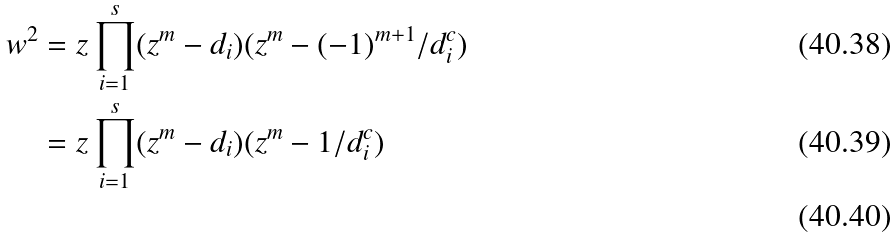<formula> <loc_0><loc_0><loc_500><loc_500>w ^ { 2 } & = z \prod _ { i = 1 } ^ { s } ( z ^ { m } - d _ { i } ) ( z ^ { m } - ( - 1 ) ^ { m + 1 } / d _ { i } ^ { c } ) \\ & = z \prod _ { i = 1 } ^ { s } ( z ^ { m } - d _ { i } ) ( z ^ { m } - 1 / d _ { i } ^ { c } ) \\</formula> 